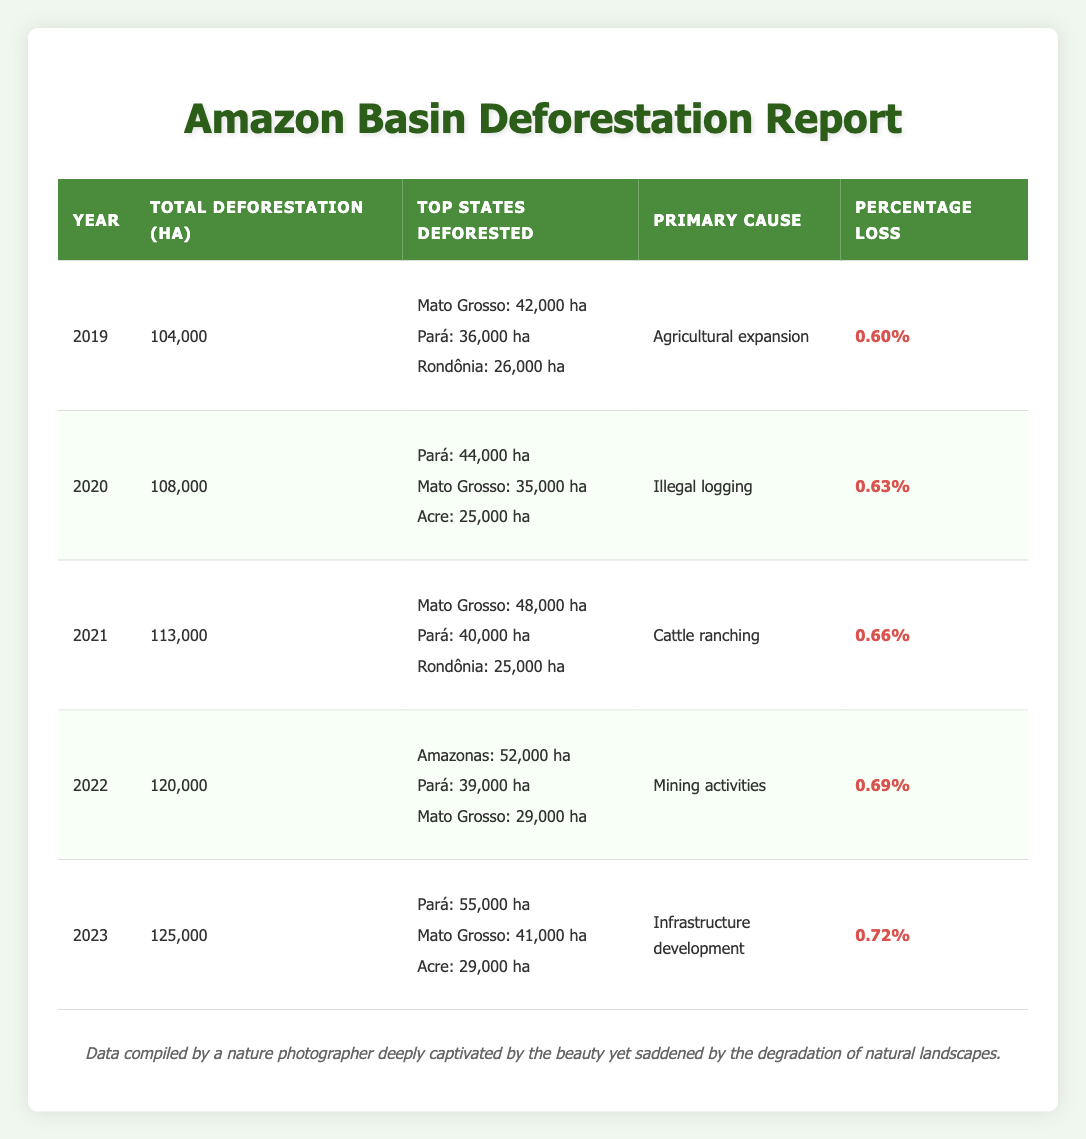What was the total deforestation area in 2021? Referring to the table, in the row for the year 2021, the total deforestation area is listed as 113,000 hectares.
Answer: 113,000 hectares Which state had the highest deforestation area in 2022? In the 2022 row, the state with the highest deforestation area is Amazonas, which had 52,000 hectares of deforestation.
Answer: Amazonas What is the increase in total deforestation area from 2019 to 2023? Calculating the total deforestation area for 2019 (104,000 hectares) and for 2023 (125,000 hectares), the increase is 125,000 - 104,000 = 21,000 hectares.
Answer: 21,000 hectares Which cause contributed to the most deforestation in 2021? In 2021, the primary cause listed for deforestation is cattle ranching, according to the table.
Answer: Cattle ranching How much deforestation occurred in Pará in 2023? From the 2023 row, Pará had 55,000 hectares of deforestation recorded in that year.
Answer: 55,000 hectares What was the average total deforestation area over the five years from 2019 to 2023? To find the average, sum the total deforestation areas: 104,000 + 108,000 + 113,000 + 120,000 + 125,000 = 570,000 hectares. Then divide by 5 (the number of years): 570,000 / 5 = 114,000 hectares.
Answer: 114,000 hectares Is the percentage loss of deforestation always increasing from 2019 to 2023? By examining the percentage loss from the years, it’s noted that it has increased each year: 0.60, 0.63, 0.66, 0.69, and 0.72%. This confirms that it is indeed always increasing.
Answer: Yes How many hectares were lost to agricultural expansion in 2019 compared to illegal logging in 2020? In 2019, agricultural expansion caused a loss of 104,000 hectares. In 2020, illegal logging resulted in a loss of 108,000 hectares. The difference is 108,000 - 104,000 = 4,000 hectares more in 2020.
Answer: 4,000 hectares more What were the top three states deforested in 2020, and how do their areas compare to 2023's top three? In 2020, the top states were Pará (44,000 ha), Mato Grosso (35,000 ha), and Acre (25,000 ha). In 2023, they are Pará (55,000 ha), Mato Grosso (41,000 ha), and Acre (29,000 ha). Comparing the areas, all states showed increased deforestation in 2023 compared to 2020.
Answer: All states increased in 2023 How many hectares of deforestation were attributed to the primary cause of mining activities in 2022? Referring to the 2022 row, it shows that the total deforestation area was 120,000 hectares. Mining activities were the primary cause, contributing significantly to that total, but their specific contribution within the total isn't detailed in this table.
Answer: Not specified in the table 